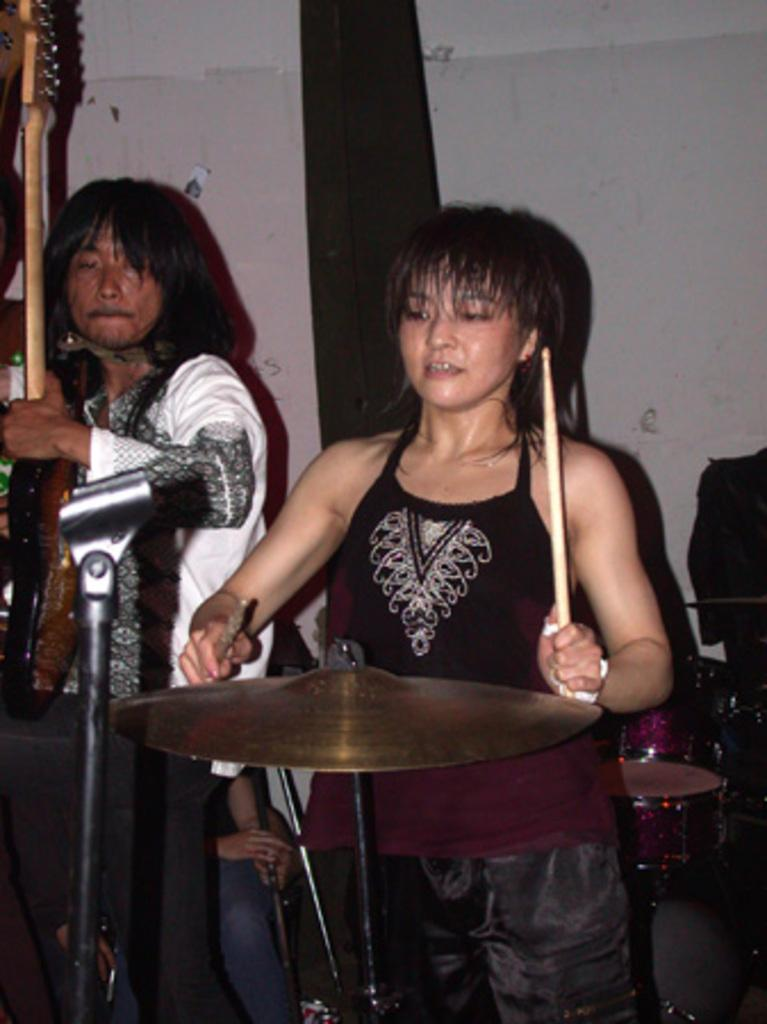How many people are in the image? There are two people in the image. What are the two people doing in the image? The two people are playing musical instruments. What can be seen in the background of the image? There is a wall in the background of the image. Can you see a gun in the image? No, there is no gun present in the image. Is the governor in the image? No, there is no governor present in the image. 